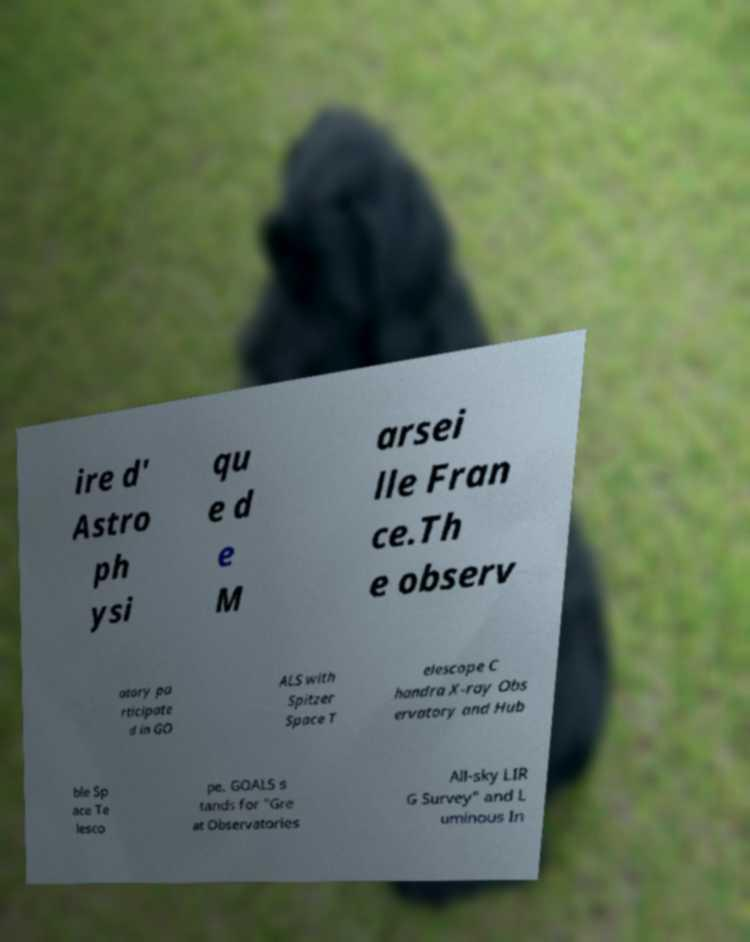For documentation purposes, I need the text within this image transcribed. Could you provide that? ire d' Astro ph ysi qu e d e M arsei lle Fran ce.Th e observ atory pa rticipate d in GO ALS with Spitzer Space T elescope C handra X-ray Obs ervatory and Hub ble Sp ace Te lesco pe. GOALS s tands for "Gre at Observatories All-sky LIR G Survey" and L uminous In 